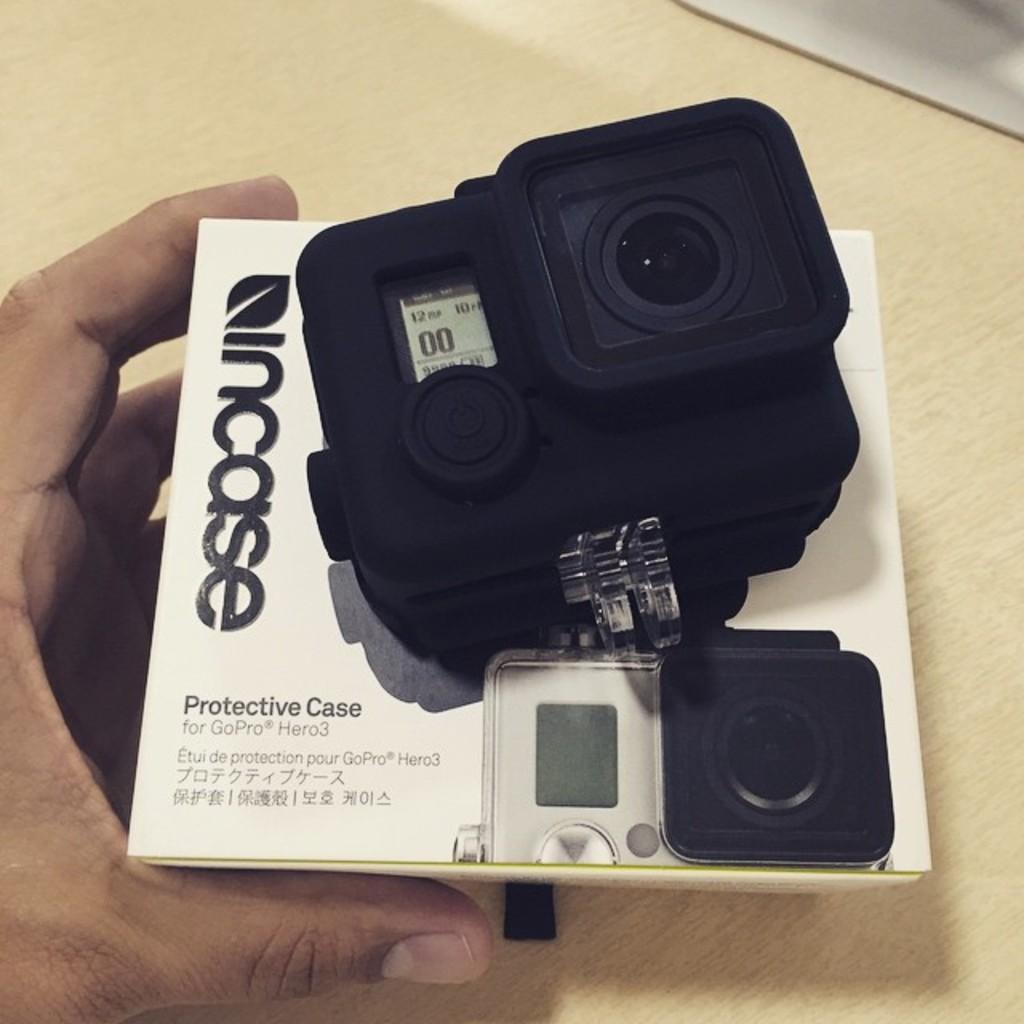Could you give a brief overview of what you see in this image? In the center of the image, we can see a person holding a box and a camera. At the bottom, there is a table. 